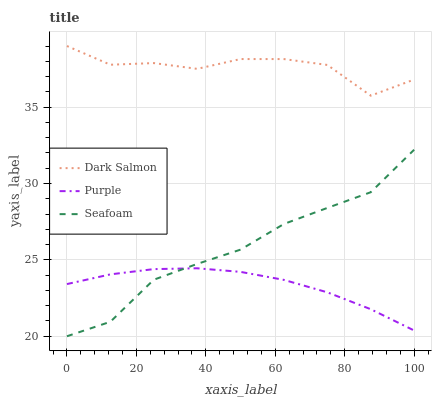Does Purple have the minimum area under the curve?
Answer yes or no. Yes. Does Dark Salmon have the maximum area under the curve?
Answer yes or no. Yes. Does Seafoam have the minimum area under the curve?
Answer yes or no. No. Does Seafoam have the maximum area under the curve?
Answer yes or no. No. Is Purple the smoothest?
Answer yes or no. Yes. Is Dark Salmon the roughest?
Answer yes or no. Yes. Is Seafoam the smoothest?
Answer yes or no. No. Is Seafoam the roughest?
Answer yes or no. No. Does Dark Salmon have the lowest value?
Answer yes or no. No. Does Seafoam have the highest value?
Answer yes or no. No. Is Seafoam less than Dark Salmon?
Answer yes or no. Yes. Is Dark Salmon greater than Purple?
Answer yes or no. Yes. Does Seafoam intersect Dark Salmon?
Answer yes or no. No. 